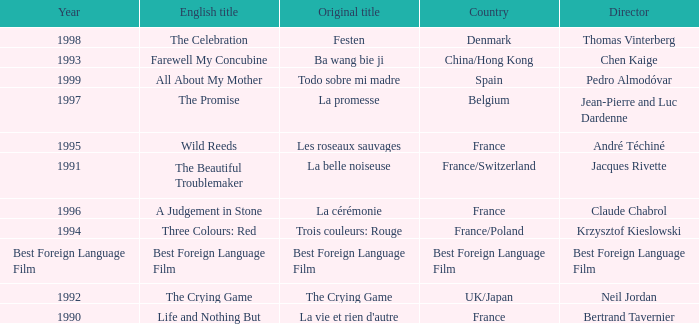Which Country has the Director Chen Kaige? China/Hong Kong. 